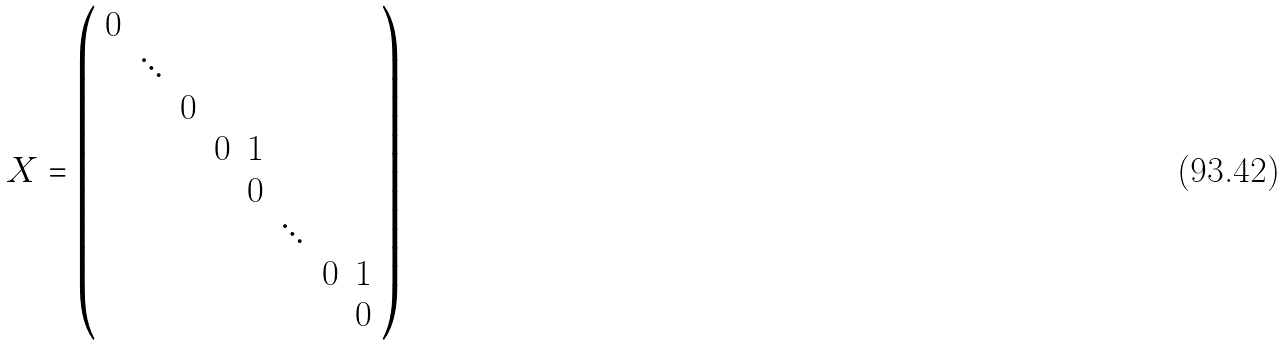Convert formula to latex. <formula><loc_0><loc_0><loc_500><loc_500>X = \left ( \begin{array} { c c c c c c c c } 0 & \\ & \ddots & \\ & & 0 \\ & & & 0 & 1 \\ & & & & 0 \\ & & & & & \ddots \\ & & & & & & 0 & 1 \\ & & & & & & & 0 \end{array} \right )</formula> 